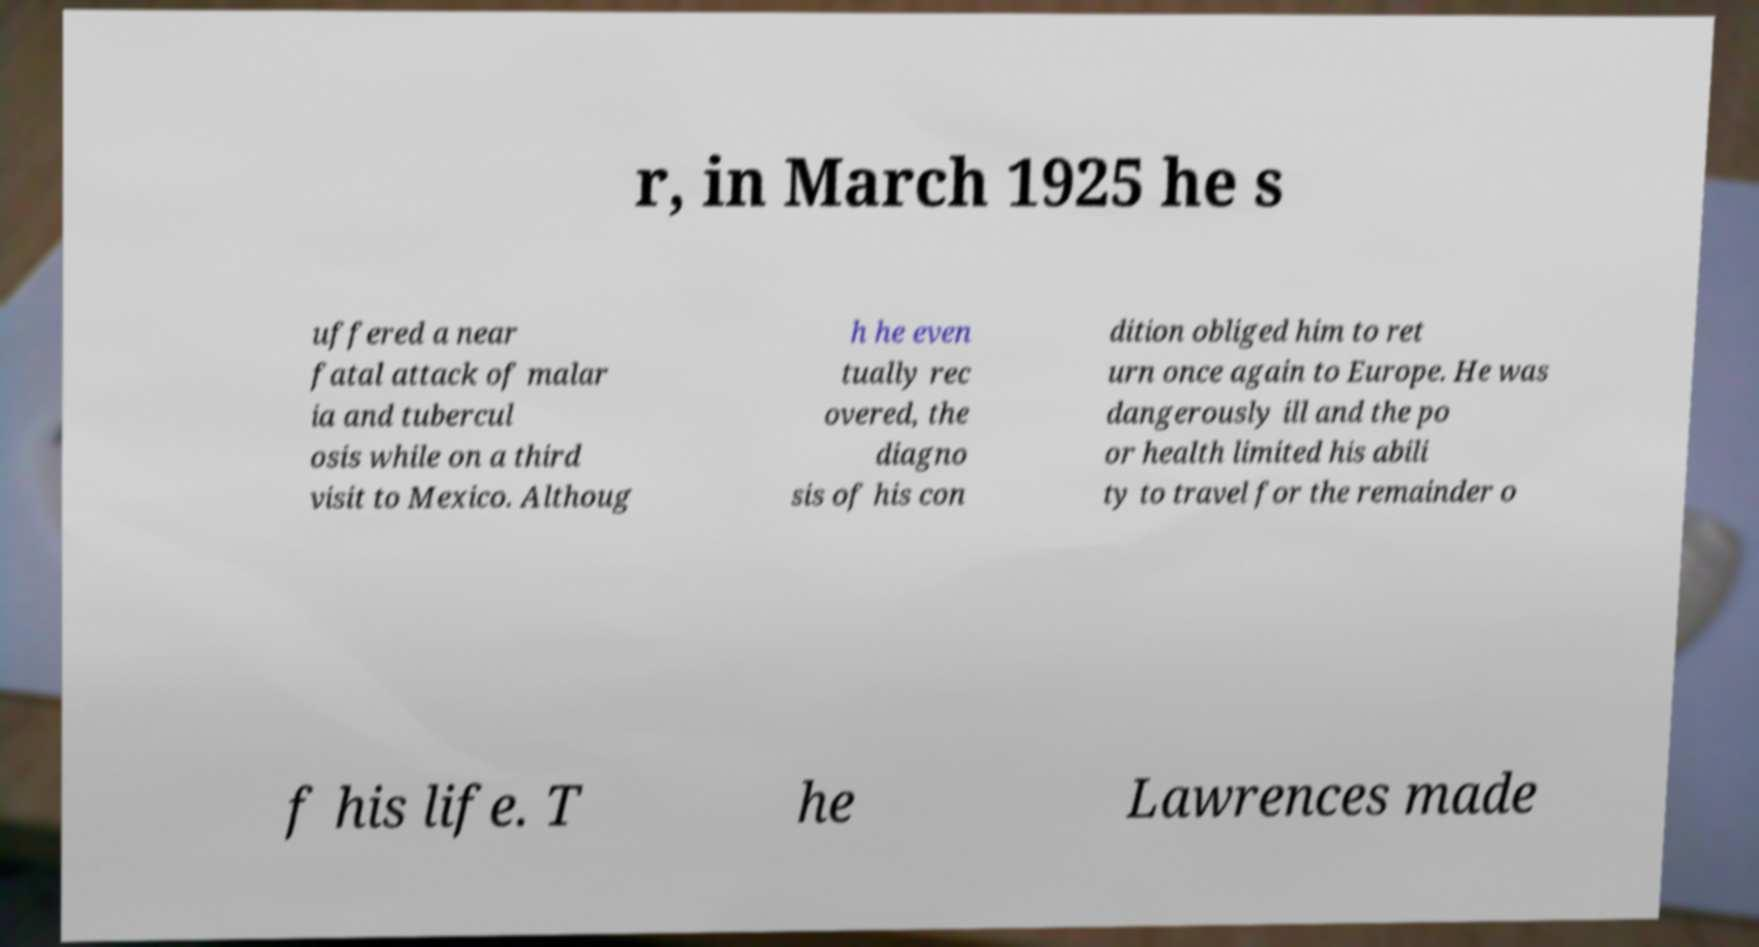For documentation purposes, I need the text within this image transcribed. Could you provide that? r, in March 1925 he s uffered a near fatal attack of malar ia and tubercul osis while on a third visit to Mexico. Althoug h he even tually rec overed, the diagno sis of his con dition obliged him to ret urn once again to Europe. He was dangerously ill and the po or health limited his abili ty to travel for the remainder o f his life. T he Lawrences made 